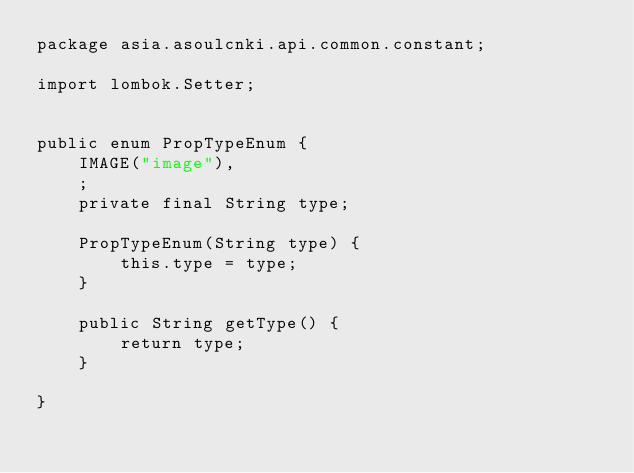<code> <loc_0><loc_0><loc_500><loc_500><_Java_>package asia.asoulcnki.api.common.constant;

import lombok.Setter;


public enum PropTypeEnum {
    IMAGE("image"),
    ;
    private final String type;

    PropTypeEnum(String type) {
        this.type = type;
    }

    public String getType() {
        return type;
    }

}
</code> 